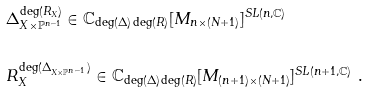<formula> <loc_0><loc_0><loc_500><loc_500>& \Delta _ { X \times \mathbb { P } ^ { n - 1 } } ^ { \deg ( R _ { X } ) } \in \mathbb { C } _ { \deg ( \Delta ) \deg ( R ) } [ M _ { n \times ( N + 1 ) } ] ^ { S L ( n , \mathbb { C } ) } \\ \ \\ & R _ { X } ^ { \deg ( \Delta _ { X \times \mathbb { P } ^ { n - 1 } } ) } \in \mathbb { C } _ { \deg ( \Delta ) \deg ( R ) } [ M _ { ( n + 1 ) \times ( N + 1 ) } ] ^ { S L ( n + 1 , \mathbb { C } ) } \ .</formula> 